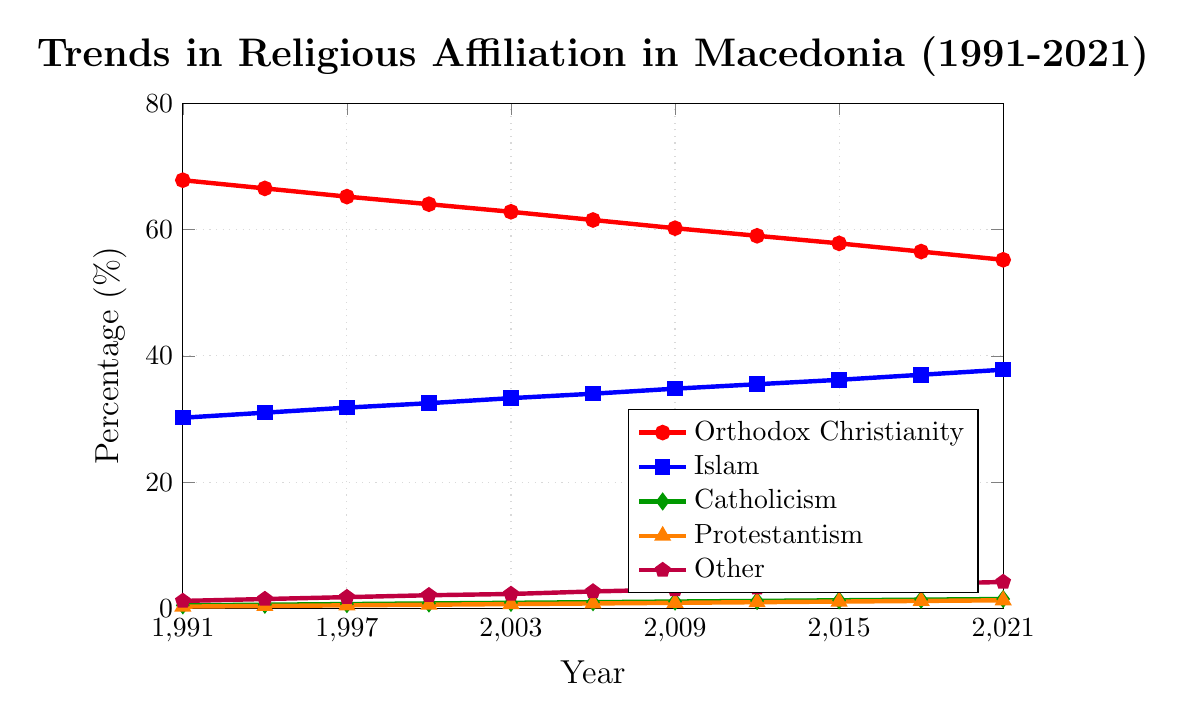What is the trend in the percentage of Orthodox Christians in Macedonia from 1991 to 2021? The percentage of Orthodox Christians shows a consistent decline from 67.8% in 1991 to 55.2% in 2021.
Answer: It declines In which year did Islam first surpass 35%? The value of Islam first exceeds 35% in 2012.
Answer: 2012 How does the trend of Protestantism compare to that of Catholicism from 1991 to 2021? Both Protestantism and Catholicism show a slow but steady increase over the years. However, Protestantism consistently has a slightly lower percentage compared to Catholicism each year.
Answer: Protestantism grows slower but is slightly behind Catholicism What is the sum of the percentages of Catholicism and Protestantism in 2021? In 2021, the percentage of Catholicism is 1.5%, and Protestantism is 1.3%. Adding them together gives 1.5% + 1.3% = 2.8%.
Answer: 2.8% Which religion has shown the most growth in percentage points from 1991 to 2021? To find the most growth in percentage points, calculate the difference for each religion between 2021 and 1991. Orthodox Christianity: -12.6, Islam: +7.6, Catholicism: +1, Protestantism: +1, Other: +3. The highest growth is in Islam with +7.6 percentage points.
Answer: Islam What is the change in the percentage of people following 'Other' religions from 1991 to 2021? The percentage of 'Other' religions in 1991 is 1.2% and in 2021 is 4.2%. The change is 4.2% - 1.2% = +3%.
Answer: +3% What was the percentage difference between Orthodox Christianity and Islam in 2000? In 2000, the percentage of Orthodox Christianity is 64.0%, and Islam is 32.5%. The difference is 64.0% - 32.5% = 31.5%.
Answer: 31.5% Between which consecutive years did Orthodox Christianity see the largest drop in percentage? By comparing the drop in consecutive years:
1991-1994: 67.8 - 66.5 = 1.3
1994-1997: 66.5 - 65.2 = 1.3
1997-2000: 65.2 - 64.0 = 1.2
2000-2003: 64.0 - 62.8 = 1.2
2003-2006: 62.8 - 61.5 = 1.3
2006-2009: 61.5 - 60.2 = 1.3
2009-2012: 60.2 - 59.0 = 1.2
2012-2015: 59.0 - 57.8 = 1.2
2015-2018: 57.8 - 56.5 = 1.3
2018-2021: 56.5 - 55.2 = 1.3
The years 1991-1994, 2003-2006, 2006-2009, 2015-2018, and 2018-2021 have the largest drop of 1.3%.
Answer: 1991-1994, 2003-2006, 2006-2009, 2015-2018, and 2018-2021. (1.3% drop) What is the approximate average percentage of the 'Other' category from 1991 to 2021? Summing up the 'Other' percentages: 1.2 + 1.5 + 1.8 + 2.1 + 2.3 + 2.7 + 3.0 + 3.3 + 3.6 + 3.9 + 4.2 = 29.6. Divide by the number of years (11): 29.6 / 11 = 2.69.
Answer: 2.69% By what percentage did Catholicism increase between 1991 and 2021? The percentage in 1991 is 0.5%, and in 2021 it is 1.5%. The increase is 1.5% - 0.5% = 1%.
Answer: 1% 